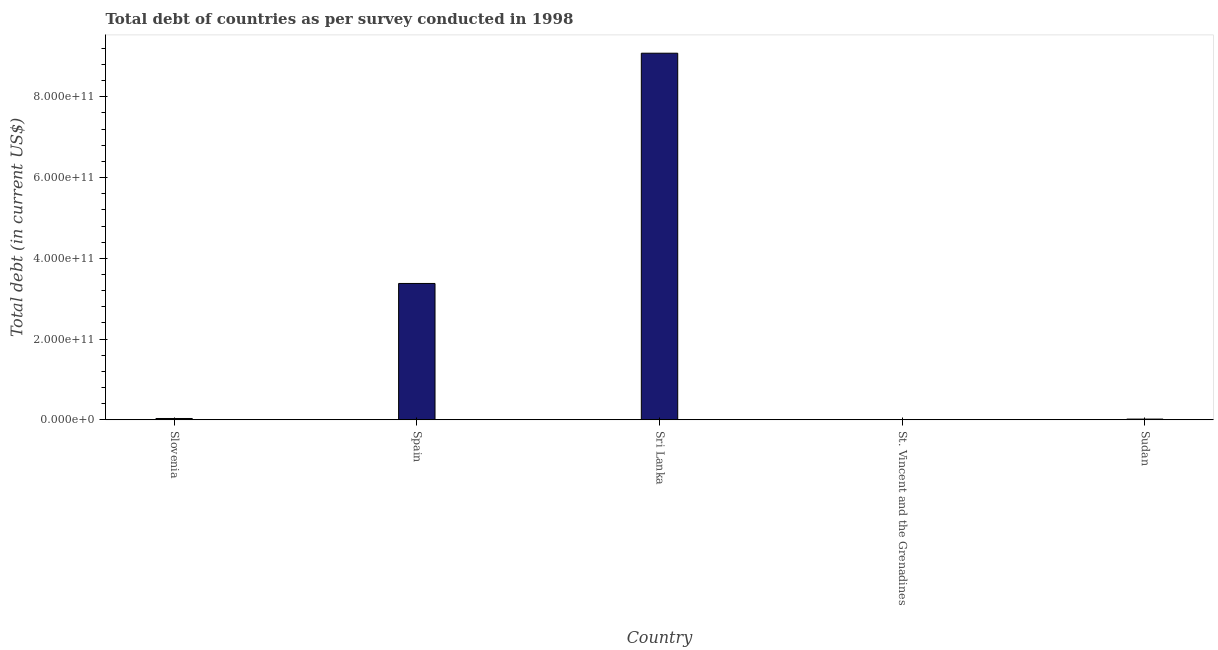What is the title of the graph?
Offer a very short reply. Total debt of countries as per survey conducted in 1998. What is the label or title of the Y-axis?
Ensure brevity in your answer.  Total debt (in current US$). What is the total debt in Sri Lanka?
Ensure brevity in your answer.  9.08e+11. Across all countries, what is the maximum total debt?
Provide a succinct answer. 9.08e+11. Across all countries, what is the minimum total debt?
Keep it short and to the point. 4.04e+08. In which country was the total debt maximum?
Ensure brevity in your answer.  Sri Lanka. In which country was the total debt minimum?
Give a very brief answer. St. Vincent and the Grenadines. What is the sum of the total debt?
Ensure brevity in your answer.  1.25e+12. What is the difference between the total debt in Spain and Sri Lanka?
Offer a terse response. -5.70e+11. What is the average total debt per country?
Give a very brief answer. 2.50e+11. What is the median total debt?
Offer a terse response. 3.24e+09. What is the ratio of the total debt in Slovenia to that in St. Vincent and the Grenadines?
Make the answer very short. 8.02. Is the difference between the total debt in Spain and Sudan greater than the difference between any two countries?
Ensure brevity in your answer.  No. What is the difference between the highest and the second highest total debt?
Ensure brevity in your answer.  5.70e+11. What is the difference between the highest and the lowest total debt?
Provide a succinct answer. 9.08e+11. What is the difference between two consecutive major ticks on the Y-axis?
Give a very brief answer. 2.00e+11. What is the Total debt (in current US$) in Slovenia?
Your response must be concise. 3.24e+09. What is the Total debt (in current US$) of Spain?
Your answer should be very brief. 3.38e+11. What is the Total debt (in current US$) of Sri Lanka?
Your answer should be compact. 9.08e+11. What is the Total debt (in current US$) of St. Vincent and the Grenadines?
Keep it short and to the point. 4.04e+08. What is the Total debt (in current US$) of Sudan?
Your response must be concise. 1.78e+09. What is the difference between the Total debt (in current US$) in Slovenia and Spain?
Your response must be concise. -3.34e+11. What is the difference between the Total debt (in current US$) in Slovenia and Sri Lanka?
Offer a very short reply. -9.05e+11. What is the difference between the Total debt (in current US$) in Slovenia and St. Vincent and the Grenadines?
Your answer should be very brief. 2.84e+09. What is the difference between the Total debt (in current US$) in Slovenia and Sudan?
Your response must be concise. 1.46e+09. What is the difference between the Total debt (in current US$) in Spain and Sri Lanka?
Your answer should be very brief. -5.70e+11. What is the difference between the Total debt (in current US$) in Spain and St. Vincent and the Grenadines?
Your response must be concise. 3.37e+11. What is the difference between the Total debt (in current US$) in Spain and Sudan?
Provide a short and direct response. 3.36e+11. What is the difference between the Total debt (in current US$) in Sri Lanka and St. Vincent and the Grenadines?
Provide a succinct answer. 9.08e+11. What is the difference between the Total debt (in current US$) in Sri Lanka and Sudan?
Your answer should be compact. 9.06e+11. What is the difference between the Total debt (in current US$) in St. Vincent and the Grenadines and Sudan?
Make the answer very short. -1.37e+09. What is the ratio of the Total debt (in current US$) in Slovenia to that in Spain?
Your answer should be compact. 0.01. What is the ratio of the Total debt (in current US$) in Slovenia to that in Sri Lanka?
Keep it short and to the point. 0. What is the ratio of the Total debt (in current US$) in Slovenia to that in St. Vincent and the Grenadines?
Ensure brevity in your answer.  8.02. What is the ratio of the Total debt (in current US$) in Slovenia to that in Sudan?
Offer a terse response. 1.82. What is the ratio of the Total debt (in current US$) in Spain to that in Sri Lanka?
Your answer should be very brief. 0.37. What is the ratio of the Total debt (in current US$) in Spain to that in St. Vincent and the Grenadines?
Offer a very short reply. 836.09. What is the ratio of the Total debt (in current US$) in Spain to that in Sudan?
Make the answer very short. 189.96. What is the ratio of the Total debt (in current US$) in Sri Lanka to that in St. Vincent and the Grenadines?
Provide a succinct answer. 2248.08. What is the ratio of the Total debt (in current US$) in Sri Lanka to that in Sudan?
Keep it short and to the point. 510.75. What is the ratio of the Total debt (in current US$) in St. Vincent and the Grenadines to that in Sudan?
Your answer should be compact. 0.23. 